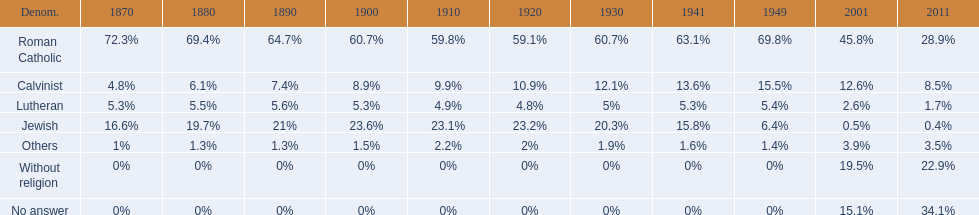Which denomination percentage increased the most after 1949? Without religion. 